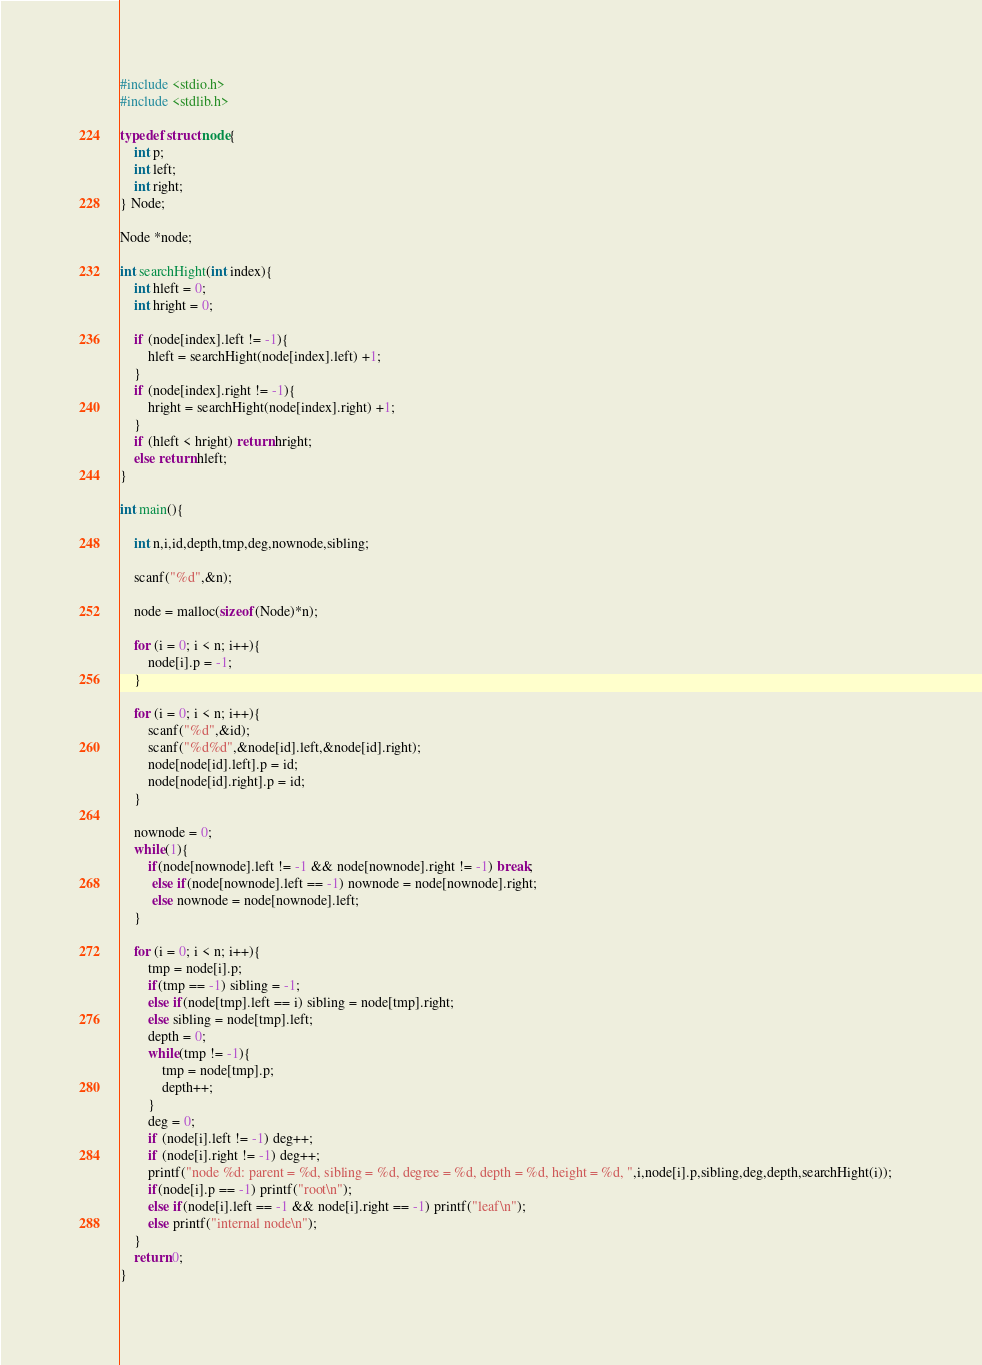Convert code to text. <code><loc_0><loc_0><loc_500><loc_500><_C_>#include <stdio.h>
#include <stdlib.h>
   
typedef struct node{
    int p;
    int left;
    int right;
} Node;

Node *node;

int searchHight(int index){
    int hleft = 0;
    int hright = 0;
   
    if (node[index].left != -1){
        hleft = searchHight(node[index].left) +1;
    }
    if (node[index].right != -1){
        hright = searchHight(node[index].right) +1;
    }
    if (hleft < hright) return hright;
    else return hleft;
}
   
int main(){
       
    int n,i,id,depth,tmp,deg,nownode,sibling;
   
    scanf("%d",&n);
   
    node = malloc(sizeof(Node)*n);
   
    for (i = 0; i < n; i++){
        node[i].p = -1;
    }
   
    for (i = 0; i < n; i++){
        scanf("%d",&id);
        scanf("%d%d",&node[id].left,&node[id].right);
        node[node[id].left].p = id;
        node[node[id].right].p = id;
    }
   
    nownode = 0;
    while(1){
        if(node[nownode].left != -1 && node[nownode].right != -1) break;
         else if(node[nownode].left == -1) nownode = node[nownode].right;
         else nownode = node[nownode].left;       
    }
   
    for (i = 0; i < n; i++){           
        tmp = node[i].p;
        if(tmp == -1) sibling = -1;
        else if(node[tmp].left == i) sibling = node[tmp].right;
        else sibling = node[tmp].left; 
        depth = 0;
        while(tmp != -1){
            tmp = node[tmp].p;
            depth++;
        }    
        deg = 0;
        if (node[i].left != -1) deg++;
        if (node[i].right != -1) deg++;   
        printf("node %d: parent = %d, sibling = %d, degree = %d, depth = %d, height = %d, ",i,node[i].p,sibling,deg,depth,searchHight(i));   
        if(node[i].p == -1) printf("root\n");
        else if(node[i].left == -1 && node[i].right == -1) printf("leaf\n");
        else printf("internal node\n");
    }
    return 0;
}</code> 